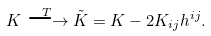Convert formula to latex. <formula><loc_0><loc_0><loc_500><loc_500>K \stackrel { T } { \longrightarrow } \tilde { K } = K - 2 K _ { i j } h ^ { i j } .</formula> 